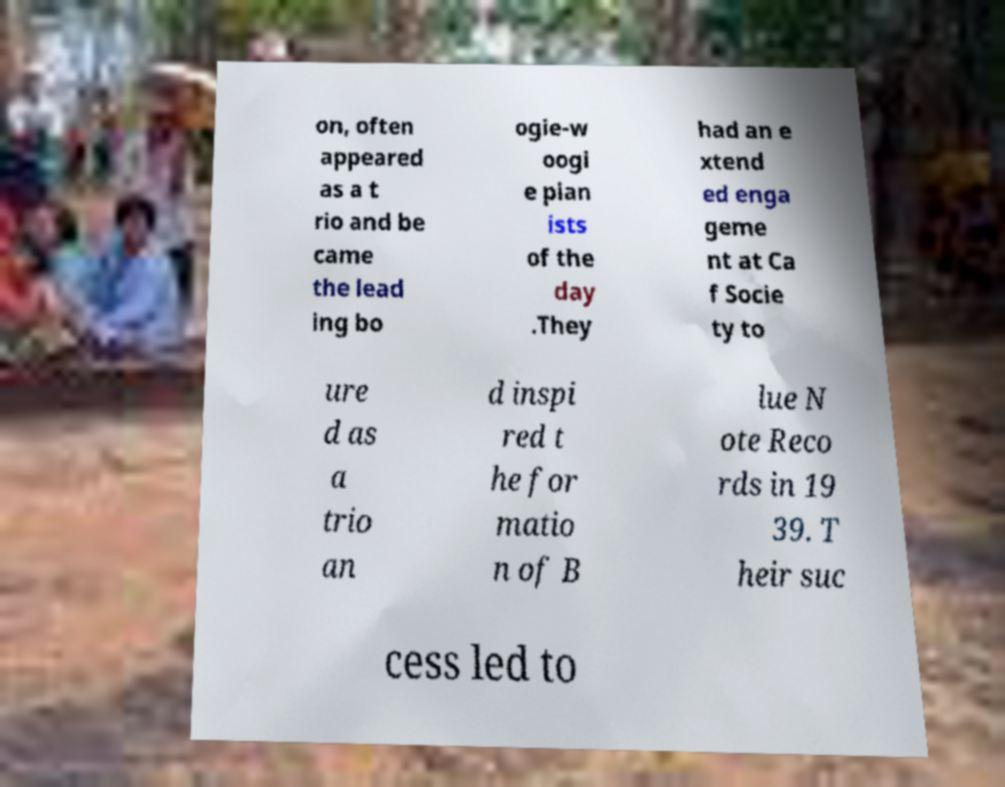I need the written content from this picture converted into text. Can you do that? on, often appeared as a t rio and be came the lead ing bo ogie-w oogi e pian ists of the day .They had an e xtend ed enga geme nt at Ca f Socie ty to ure d as a trio an d inspi red t he for matio n of B lue N ote Reco rds in 19 39. T heir suc cess led to 